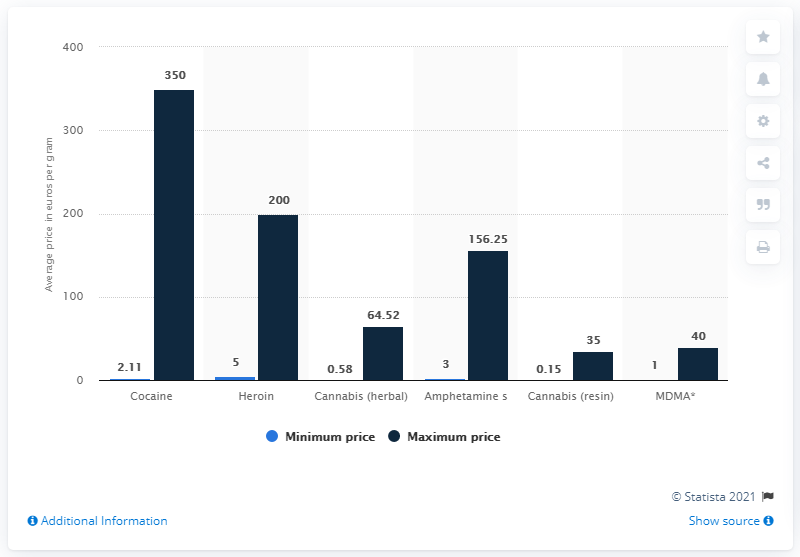Why might there be such a significant difference between the minimum and maximum prices for certain drugs? The difference between the minimum and maximum prices for drugs can be attributed to various factors, such as purity levels, the size of the purchase (wholesale vs. retail), geographical area, market fluctuations, and the costs related to the risk of smuggling and distribution. The chart reflects how these factors can lead to a wide price range for illicit substances in different scenarios. 